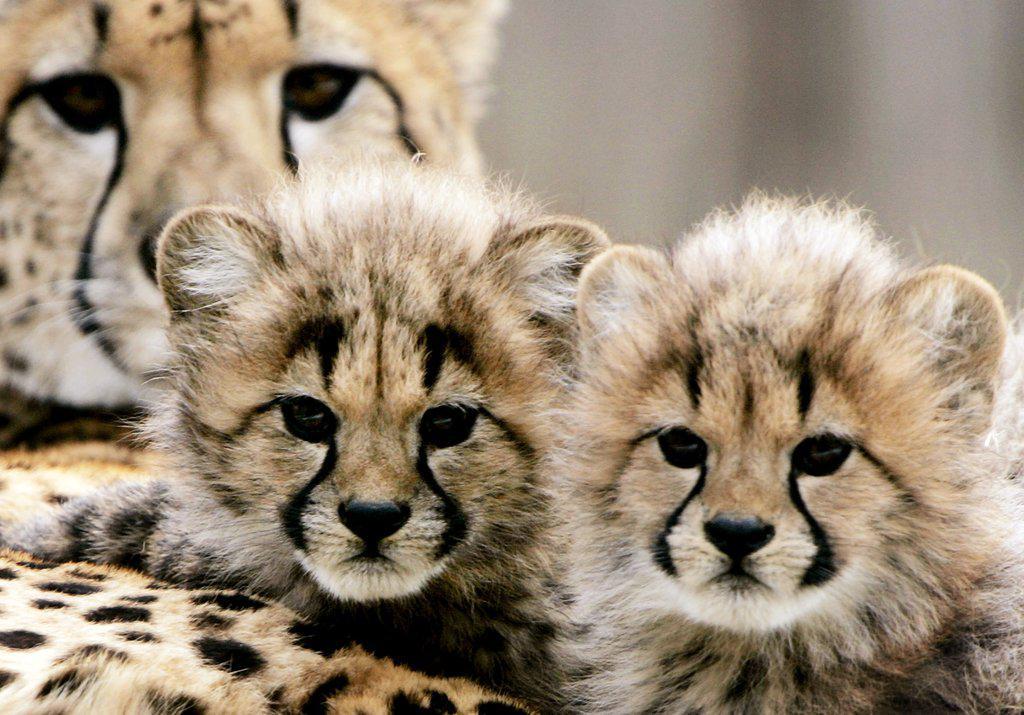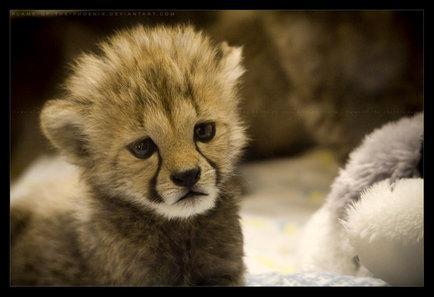The first image is the image on the left, the second image is the image on the right. For the images displayed, is the sentence "The left image contains exactly three cheetahs." factually correct? Answer yes or no. Yes. The first image is the image on the left, the second image is the image on the right. Examine the images to the left and right. Is the description "At least three cubs and one adult leopard are visible." accurate? Answer yes or no. Yes. 